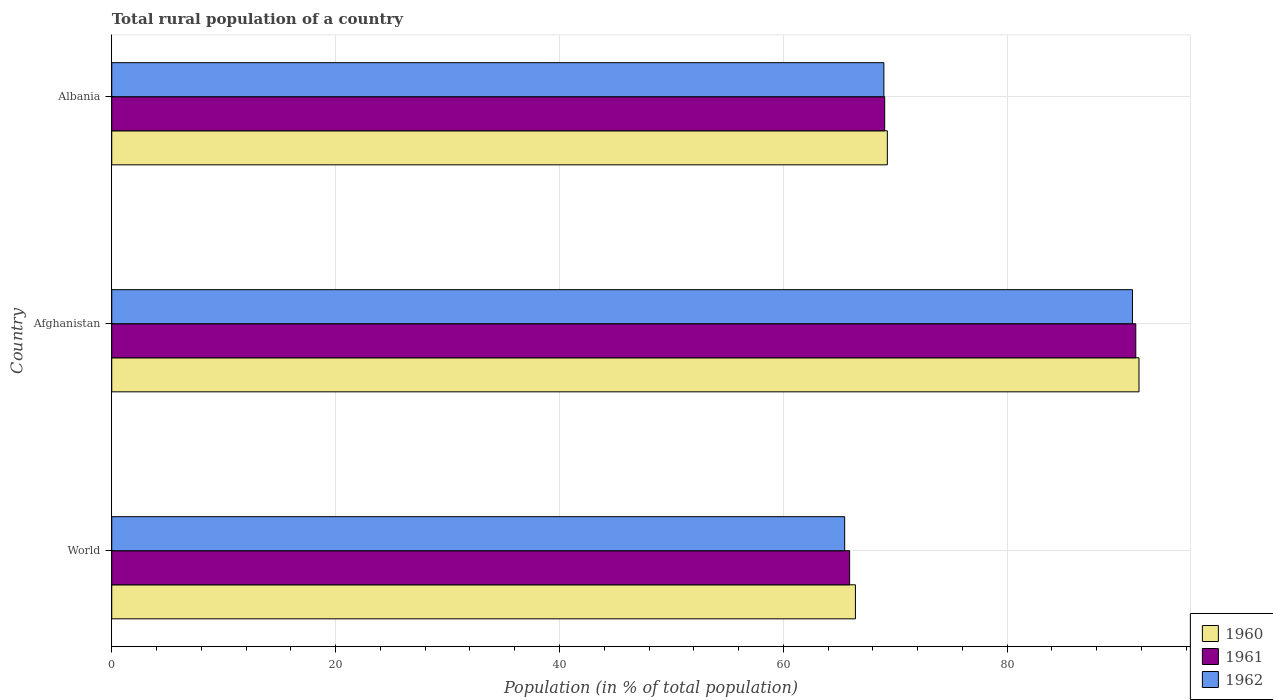Are the number of bars per tick equal to the number of legend labels?
Your response must be concise. Yes. How many bars are there on the 3rd tick from the bottom?
Provide a short and direct response. 3. What is the label of the 3rd group of bars from the top?
Offer a terse response. World. In how many cases, is the number of bars for a given country not equal to the number of legend labels?
Make the answer very short. 0. What is the rural population in 1961 in Albania?
Give a very brief answer. 69.06. Across all countries, what is the maximum rural population in 1961?
Your answer should be very brief. 91.49. Across all countries, what is the minimum rural population in 1960?
Provide a succinct answer. 66.44. In which country was the rural population in 1960 maximum?
Provide a short and direct response. Afghanistan. In which country was the rural population in 1961 minimum?
Give a very brief answer. World. What is the total rural population in 1962 in the graph?
Your answer should be very brief. 225.66. What is the difference between the rural population in 1962 in Albania and that in World?
Offer a very short reply. 3.5. What is the difference between the rural population in 1960 in Albania and the rural population in 1962 in World?
Your answer should be very brief. 3.81. What is the average rural population in 1962 per country?
Keep it short and to the point. 75.22. What is the difference between the rural population in 1960 and rural population in 1962 in Albania?
Provide a succinct answer. 0.31. In how many countries, is the rural population in 1962 greater than 8 %?
Provide a short and direct response. 3. What is the ratio of the rural population in 1961 in Afghanistan to that in World?
Offer a very short reply. 1.39. Is the rural population in 1960 in Albania less than that in World?
Provide a short and direct response. No. What is the difference between the highest and the second highest rural population in 1962?
Provide a succinct answer. 22.21. What is the difference between the highest and the lowest rural population in 1960?
Your response must be concise. 25.34. Is the sum of the rural population in 1961 in Afghanistan and Albania greater than the maximum rural population in 1960 across all countries?
Give a very brief answer. Yes. What does the 1st bar from the top in Afghanistan represents?
Keep it short and to the point. 1962. What does the 2nd bar from the bottom in Afghanistan represents?
Give a very brief answer. 1961. Is it the case that in every country, the sum of the rural population in 1961 and rural population in 1960 is greater than the rural population in 1962?
Your answer should be very brief. Yes. How many bars are there?
Keep it short and to the point. 9. How many countries are there in the graph?
Offer a terse response. 3. What is the difference between two consecutive major ticks on the X-axis?
Your response must be concise. 20. Are the values on the major ticks of X-axis written in scientific E-notation?
Give a very brief answer. No. Does the graph contain any zero values?
Offer a very short reply. No. How many legend labels are there?
Offer a terse response. 3. How are the legend labels stacked?
Offer a very short reply. Vertical. What is the title of the graph?
Offer a terse response. Total rural population of a country. Does "1965" appear as one of the legend labels in the graph?
Make the answer very short. No. What is the label or title of the X-axis?
Your answer should be compact. Population (in % of total population). What is the Population (in % of total population) in 1960 in World?
Keep it short and to the point. 66.44. What is the Population (in % of total population) in 1961 in World?
Give a very brief answer. 65.93. What is the Population (in % of total population) of 1962 in World?
Your answer should be very brief. 65.48. What is the Population (in % of total population) of 1960 in Afghanistan?
Keep it short and to the point. 91.78. What is the Population (in % of total population) of 1961 in Afghanistan?
Make the answer very short. 91.49. What is the Population (in % of total population) of 1962 in Afghanistan?
Offer a terse response. 91.19. What is the Population (in % of total population) of 1960 in Albania?
Your answer should be compact. 69.3. What is the Population (in % of total population) in 1961 in Albania?
Keep it short and to the point. 69.06. What is the Population (in % of total population) of 1962 in Albania?
Your answer should be very brief. 68.98. Across all countries, what is the maximum Population (in % of total population) of 1960?
Your answer should be compact. 91.78. Across all countries, what is the maximum Population (in % of total population) in 1961?
Ensure brevity in your answer.  91.49. Across all countries, what is the maximum Population (in % of total population) in 1962?
Offer a terse response. 91.19. Across all countries, what is the minimum Population (in % of total population) in 1960?
Give a very brief answer. 66.44. Across all countries, what is the minimum Population (in % of total population) of 1961?
Offer a terse response. 65.93. Across all countries, what is the minimum Population (in % of total population) in 1962?
Your answer should be very brief. 65.48. What is the total Population (in % of total population) in 1960 in the graph?
Your answer should be compact. 227.52. What is the total Population (in % of total population) in 1961 in the graph?
Keep it short and to the point. 226.48. What is the total Population (in % of total population) of 1962 in the graph?
Keep it short and to the point. 225.66. What is the difference between the Population (in % of total population) in 1960 in World and that in Afghanistan?
Provide a short and direct response. -25.34. What is the difference between the Population (in % of total population) of 1961 in World and that in Afghanistan?
Offer a terse response. -25.57. What is the difference between the Population (in % of total population) in 1962 in World and that in Afghanistan?
Provide a short and direct response. -25.71. What is the difference between the Population (in % of total population) in 1960 in World and that in Albania?
Give a very brief answer. -2.85. What is the difference between the Population (in % of total population) of 1961 in World and that in Albania?
Provide a short and direct response. -3.13. What is the difference between the Population (in % of total population) of 1962 in World and that in Albania?
Make the answer very short. -3.5. What is the difference between the Population (in % of total population) in 1960 in Afghanistan and that in Albania?
Offer a very short reply. 22.48. What is the difference between the Population (in % of total population) of 1961 in Afghanistan and that in Albania?
Make the answer very short. 22.43. What is the difference between the Population (in % of total population) in 1962 in Afghanistan and that in Albania?
Provide a short and direct response. 22.21. What is the difference between the Population (in % of total population) in 1960 in World and the Population (in % of total population) in 1961 in Afghanistan?
Provide a short and direct response. -25.05. What is the difference between the Population (in % of total population) of 1960 in World and the Population (in % of total population) of 1962 in Afghanistan?
Provide a succinct answer. -24.75. What is the difference between the Population (in % of total population) of 1961 in World and the Population (in % of total population) of 1962 in Afghanistan?
Ensure brevity in your answer.  -25.27. What is the difference between the Population (in % of total population) in 1960 in World and the Population (in % of total population) in 1961 in Albania?
Provide a short and direct response. -2.61. What is the difference between the Population (in % of total population) of 1960 in World and the Population (in % of total population) of 1962 in Albania?
Your response must be concise. -2.54. What is the difference between the Population (in % of total population) in 1961 in World and the Population (in % of total population) in 1962 in Albania?
Your answer should be very brief. -3.06. What is the difference between the Population (in % of total population) of 1960 in Afghanistan and the Population (in % of total population) of 1961 in Albania?
Offer a very short reply. 22.72. What is the difference between the Population (in % of total population) of 1960 in Afghanistan and the Population (in % of total population) of 1962 in Albania?
Give a very brief answer. 22.79. What is the difference between the Population (in % of total population) in 1961 in Afghanistan and the Population (in % of total population) in 1962 in Albania?
Your answer should be compact. 22.51. What is the average Population (in % of total population) of 1960 per country?
Ensure brevity in your answer.  75.84. What is the average Population (in % of total population) of 1961 per country?
Your response must be concise. 75.49. What is the average Population (in % of total population) in 1962 per country?
Make the answer very short. 75.22. What is the difference between the Population (in % of total population) of 1960 and Population (in % of total population) of 1961 in World?
Your answer should be compact. 0.52. What is the difference between the Population (in % of total population) in 1960 and Population (in % of total population) in 1962 in World?
Your answer should be very brief. 0.96. What is the difference between the Population (in % of total population) in 1961 and Population (in % of total population) in 1962 in World?
Keep it short and to the point. 0.44. What is the difference between the Population (in % of total population) of 1960 and Population (in % of total population) of 1961 in Afghanistan?
Offer a very short reply. 0.29. What is the difference between the Population (in % of total population) of 1960 and Population (in % of total population) of 1962 in Afghanistan?
Your answer should be very brief. 0.58. What is the difference between the Population (in % of total population) in 1961 and Population (in % of total population) in 1962 in Afghanistan?
Provide a succinct answer. 0.3. What is the difference between the Population (in % of total population) in 1960 and Population (in % of total population) in 1961 in Albania?
Ensure brevity in your answer.  0.24. What is the difference between the Population (in % of total population) in 1960 and Population (in % of total population) in 1962 in Albania?
Your answer should be very brief. 0.31. What is the difference between the Population (in % of total population) of 1961 and Population (in % of total population) of 1962 in Albania?
Provide a short and direct response. 0.07. What is the ratio of the Population (in % of total population) in 1960 in World to that in Afghanistan?
Provide a succinct answer. 0.72. What is the ratio of the Population (in % of total population) of 1961 in World to that in Afghanistan?
Give a very brief answer. 0.72. What is the ratio of the Population (in % of total population) of 1962 in World to that in Afghanistan?
Make the answer very short. 0.72. What is the ratio of the Population (in % of total population) in 1960 in World to that in Albania?
Ensure brevity in your answer.  0.96. What is the ratio of the Population (in % of total population) of 1961 in World to that in Albania?
Give a very brief answer. 0.95. What is the ratio of the Population (in % of total population) of 1962 in World to that in Albania?
Provide a short and direct response. 0.95. What is the ratio of the Population (in % of total population) of 1960 in Afghanistan to that in Albania?
Offer a terse response. 1.32. What is the ratio of the Population (in % of total population) in 1961 in Afghanistan to that in Albania?
Provide a succinct answer. 1.32. What is the ratio of the Population (in % of total population) in 1962 in Afghanistan to that in Albania?
Make the answer very short. 1.32. What is the difference between the highest and the second highest Population (in % of total population) of 1960?
Keep it short and to the point. 22.48. What is the difference between the highest and the second highest Population (in % of total population) of 1961?
Your answer should be very brief. 22.43. What is the difference between the highest and the second highest Population (in % of total population) of 1962?
Your answer should be very brief. 22.21. What is the difference between the highest and the lowest Population (in % of total population) of 1960?
Keep it short and to the point. 25.34. What is the difference between the highest and the lowest Population (in % of total population) in 1961?
Make the answer very short. 25.57. What is the difference between the highest and the lowest Population (in % of total population) of 1962?
Your answer should be compact. 25.71. 